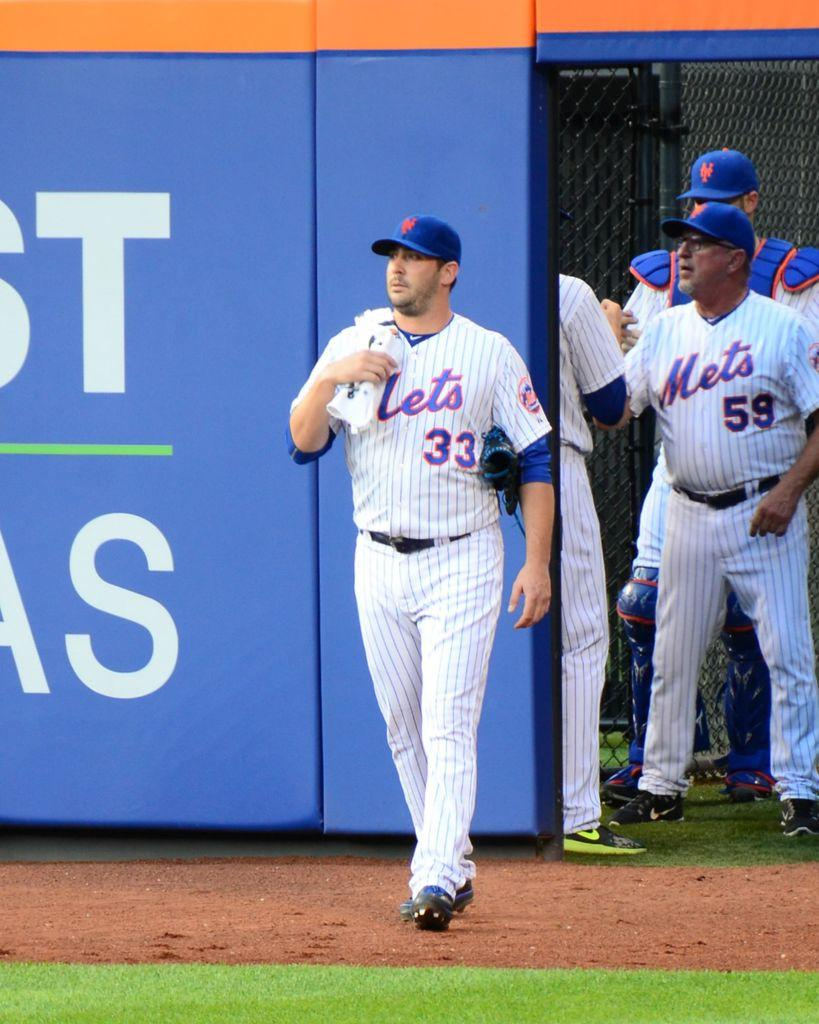Provide a one-sentence caption for the provided image. Number 33 of the New York Mets is walking from the bullpen onto the field. 